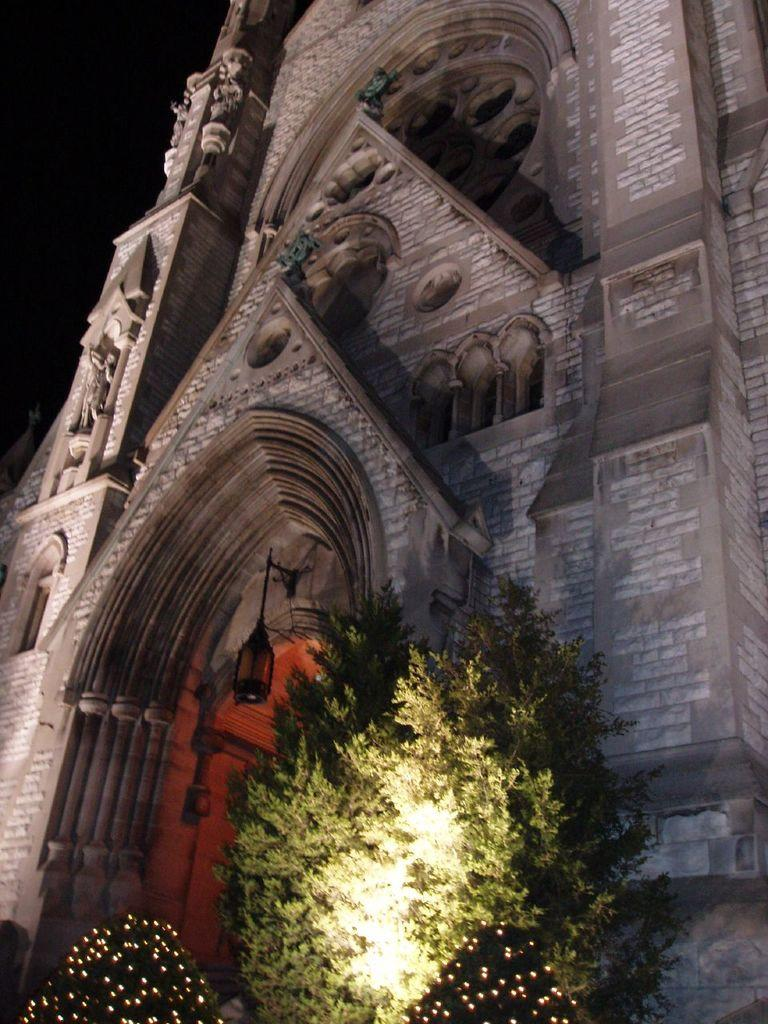What type of building is in the image? There is a church in the image. What can be seen in front of the church? There are trees in front of the church in the image. What type of toys are being used by the lawyer in the image? There are no toys or lawyers present in the image; it features a church with trees in front of it. 